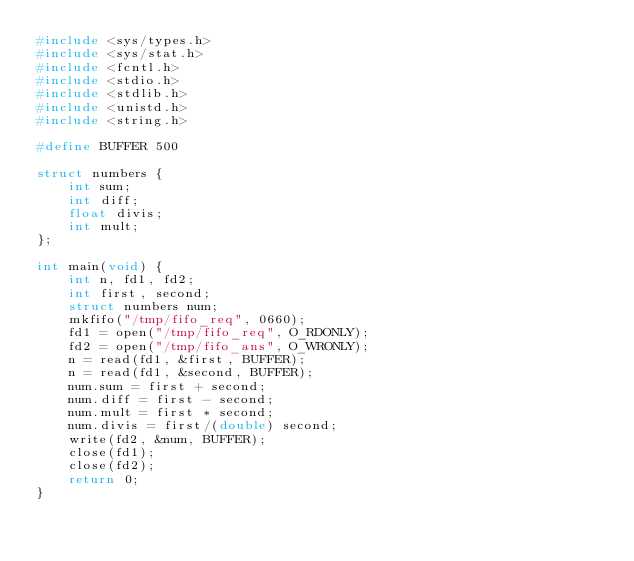Convert code to text. <code><loc_0><loc_0><loc_500><loc_500><_C_>#include <sys/types.h>
#include <sys/stat.h>
#include <fcntl.h>
#include <stdio.h>
#include <stdlib.h>
#include <unistd.h>
#include <string.h>

#define BUFFER 500

struct numbers {
    int sum;
    int diff;
    float divis;
    int mult;
};

int main(void) {
    int n, fd1, fd2;
    int first, second;
    struct numbers num;
    mkfifo("/tmp/fifo_req", 0660);
    fd1 = open("/tmp/fifo_req", O_RDONLY);
    fd2 = open("/tmp/fifo_ans", O_WRONLY);
    n = read(fd1, &first, BUFFER);
    n = read(fd1, &second, BUFFER);
    num.sum = first + second;
    num.diff = first - second;
    num.mult = first * second;
    num.divis = first/(double) second;
    write(fd2, &num, BUFFER);
    close(fd1);
    close(fd2);
    return 0;
}</code> 